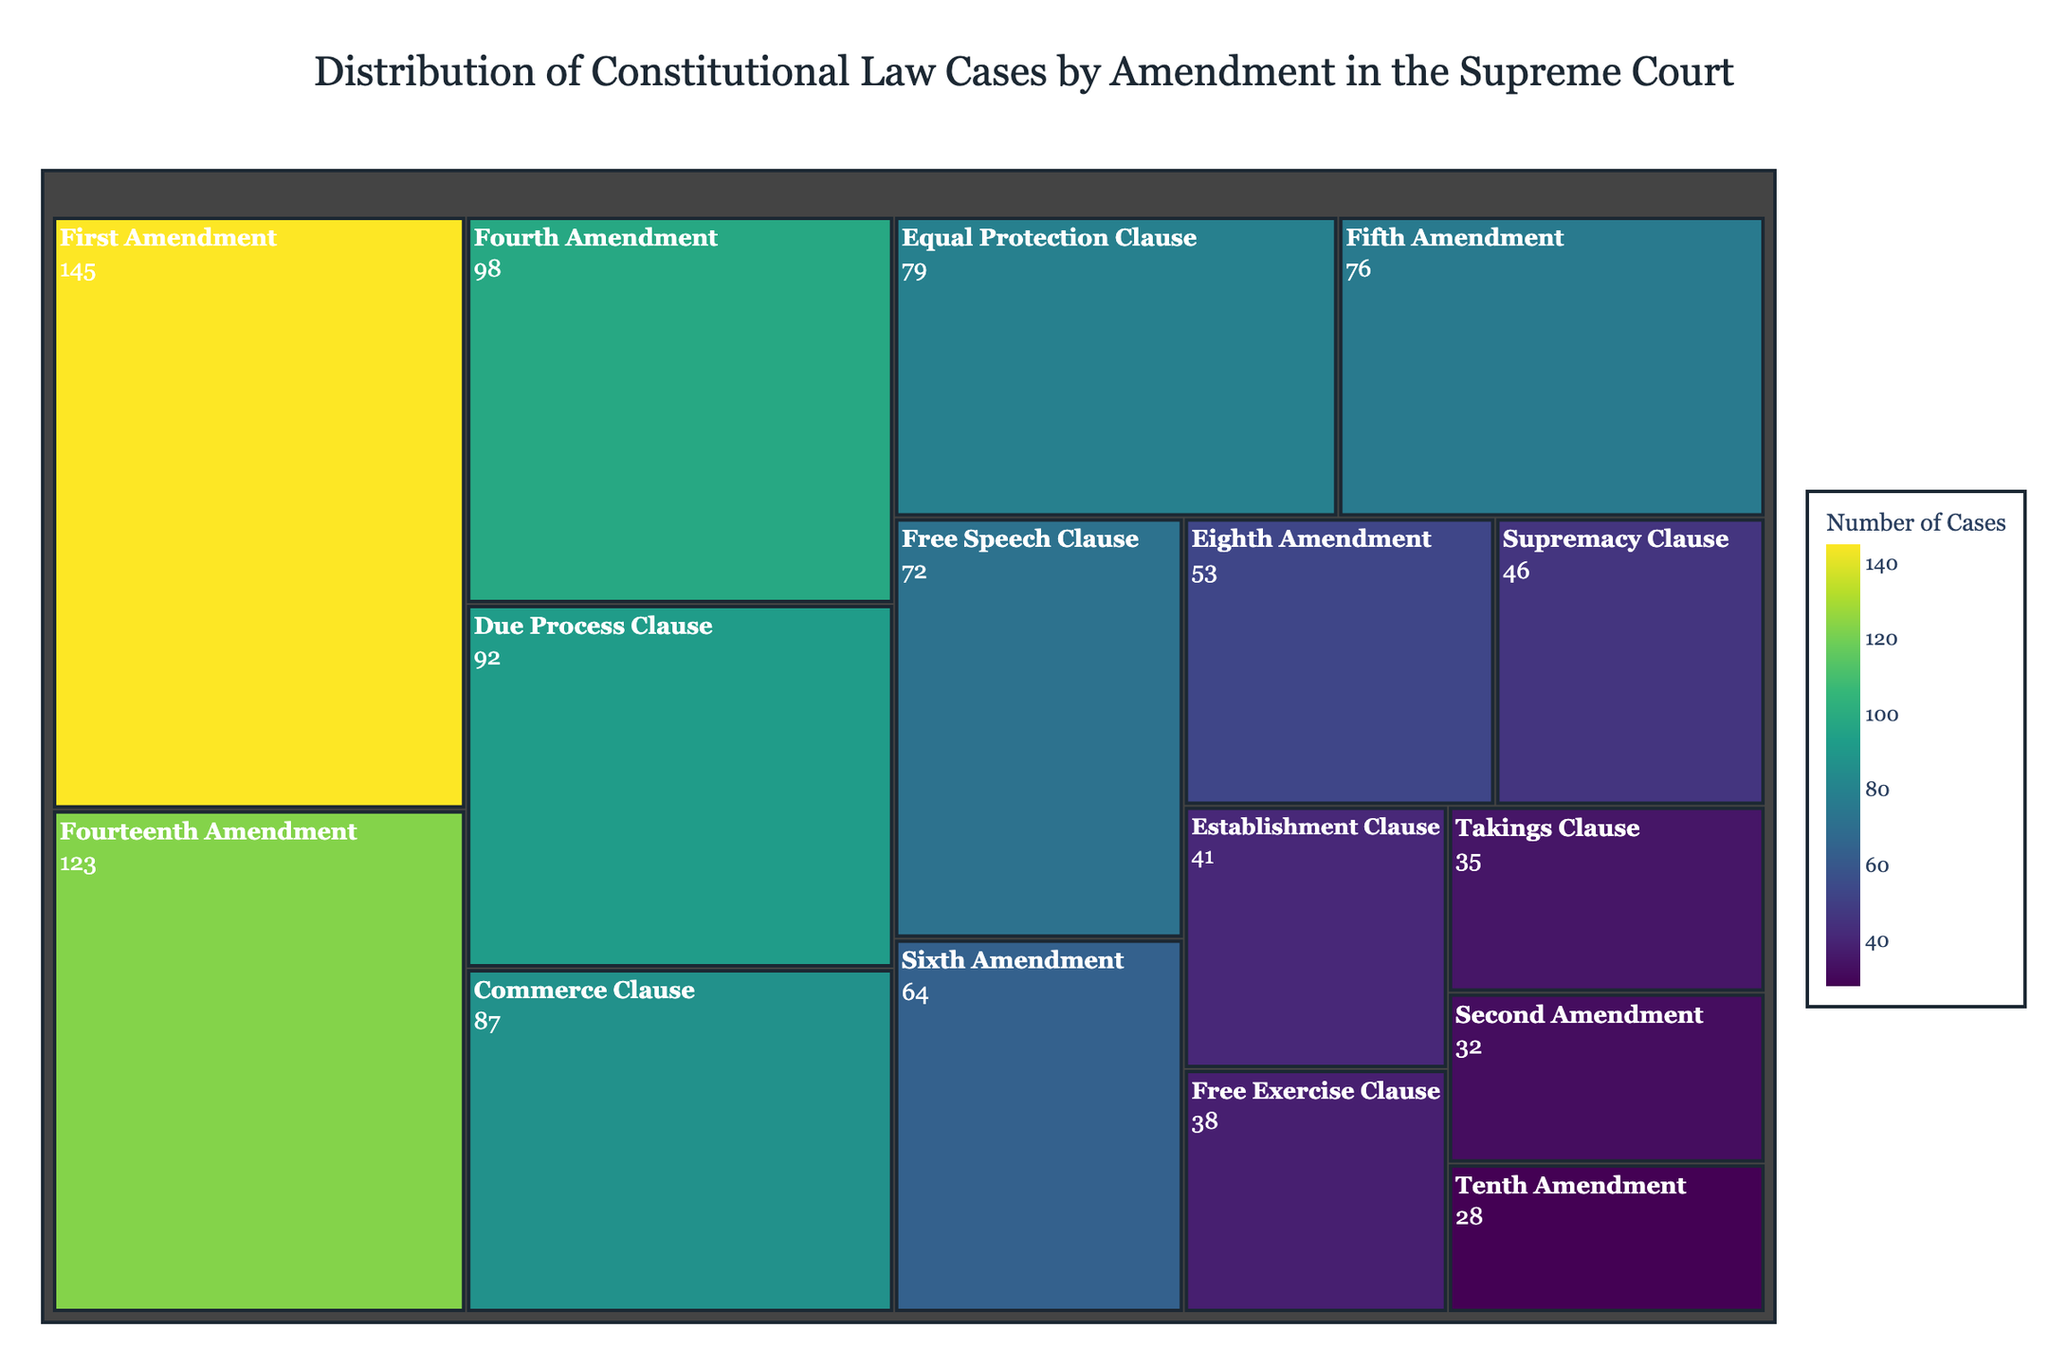Which amendment has the highest number of cases? Look for the amendment with the largest segment in the treemap and the highest value. The First Amendment has 145 cases, which is the largest number among all segments.
Answer: First Amendment How many cases are related to the Fourth and Sixth Amendments combined? Locate the Fourth Amendment and Sixth Amendment segments and add their case counts together (98 + 64). The sum is 162.
Answer: 162 Which amendment has fewer cases, the Tenth Amendment or the Establishment Clause? Compare the number of cases for the Tenth Amendment (28) and the Establishment Clause (41). The Tenth Amendment has fewer cases.
Answer: Tenth Amendment What is the difference between the number of cases for the Fifteenth Amendment and the Free Exercise Clause? Identify the segments for the Fifth Amendment (76) and the Free Exercise Clause (38) and subtract the cases for Free Exercise Clause from the Fifth Amendment (76 - 38). The difference is 38.
Answer: 38 What is the average number of cases for the Sixth, Eighth, and Takings Clause Amendments? Find the case counts for the Sixth Amendment (64), Eighth Amendment (53), and Takings Clause (35). Calculate the average: (64 + 53 + 35) / 3 = 152 / 3 = 50.67.
Answer: 50.67 Which clause has more cases, the Commerce Clause or the Due Process Clause? Compare the number of cases for the Commerce Clause (87) and the Due Process Clause (92). The Due Process Clause has more cases.
Answer: Due Process Clause What is the total number of cases related to all Amendments and Clauses combined? Sum up the case counts for all the segments. The total is 145 + 98 + 123 + 32 + 76 + 64 + 53 + 28 + 87 + 92 + 79 + 41 + 38 + 72 + 35 + 46 = 1009.
Answer: 1009 How many more cases does the Fourteenth Amendment have compared to the Second Amendment? Identify the case counts for the Fourteenth Amendment (123) and the Second Amendment (32). Subtract the Second Amendment cases from the Fourteenth Amendment cases (123 - 32). The difference is 91.
Answer: 91 Which clauses have case counts in the range of 30-40? Analyze the segments to find clauses with case counts between 30 and 40. The clauses are Free Exercise Clause (38) and Takings Clause (35).
Answer: Free Exercise Clause, Takings Clause 